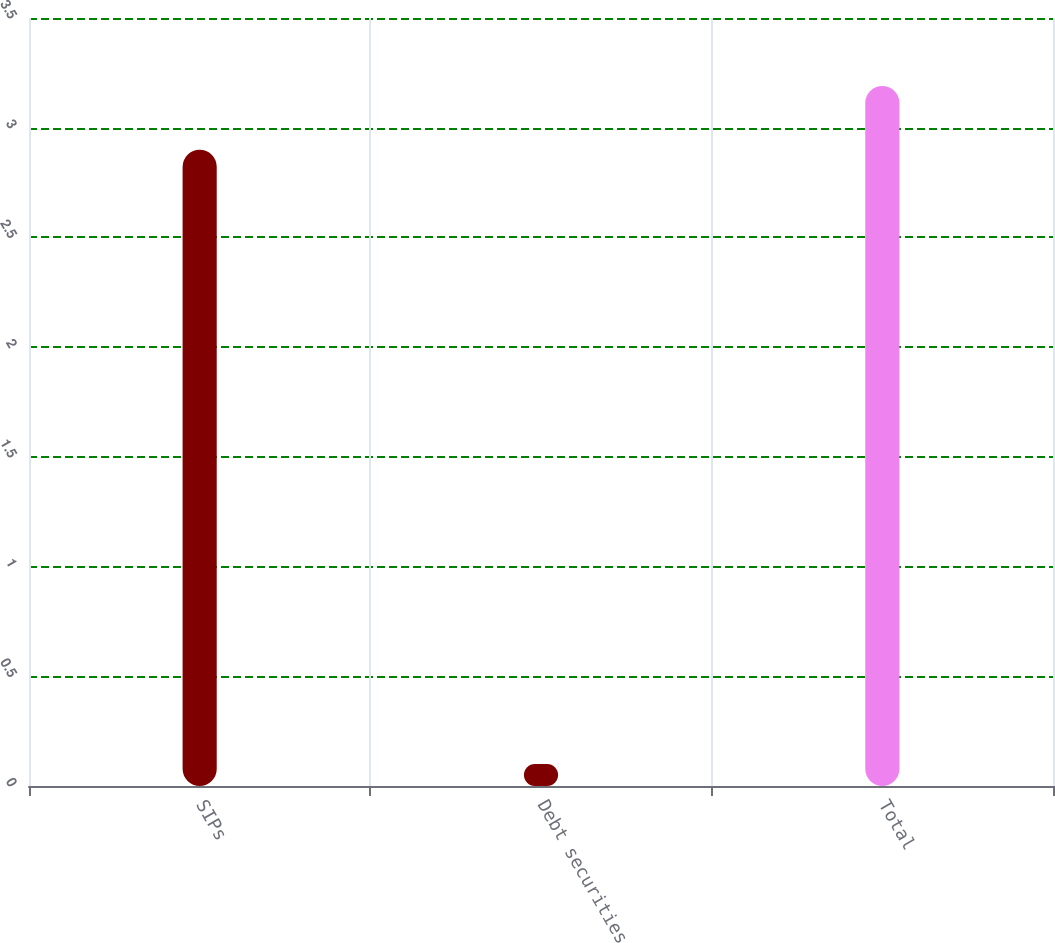<chart> <loc_0><loc_0><loc_500><loc_500><bar_chart><fcel>SIPs<fcel>Debt securities<fcel>Total<nl><fcel>2.9<fcel>0.1<fcel>3.19<nl></chart> 